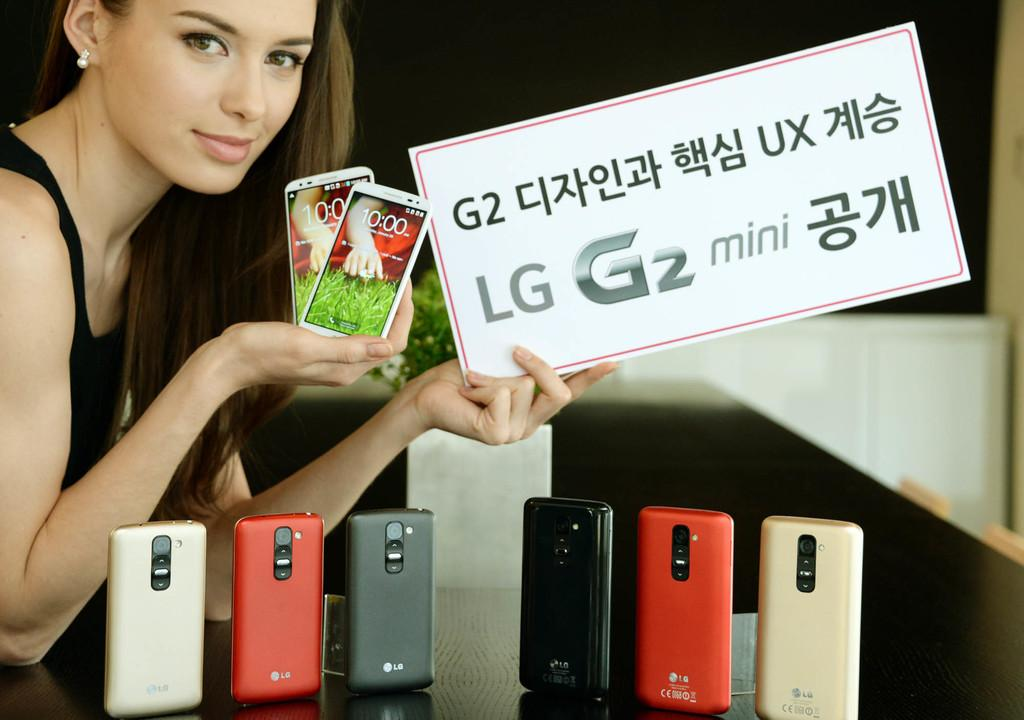Provide a one-sentence caption for the provided image. The woman is advertising LG phones and holding several of them. 